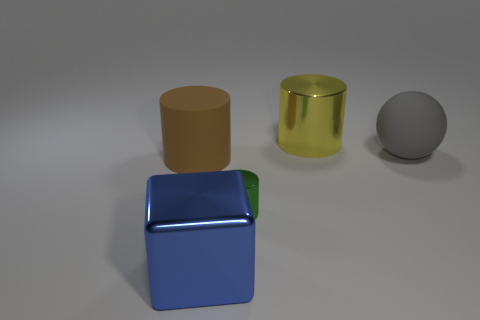Add 3 tiny brown rubber cubes. How many objects exist? 8 Subtract all cylinders. How many objects are left? 2 Add 5 blue blocks. How many blue blocks exist? 6 Subtract 1 blue blocks. How many objects are left? 4 Subtract all large gray balls. Subtract all gray cylinders. How many objects are left? 4 Add 1 large shiny cylinders. How many large shiny cylinders are left? 2 